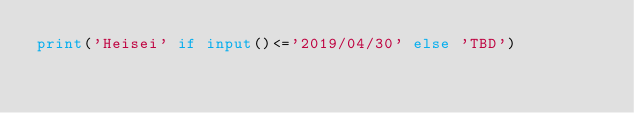<code> <loc_0><loc_0><loc_500><loc_500><_Python_>print('Heisei' if input()<='2019/04/30' else 'TBD')</code> 